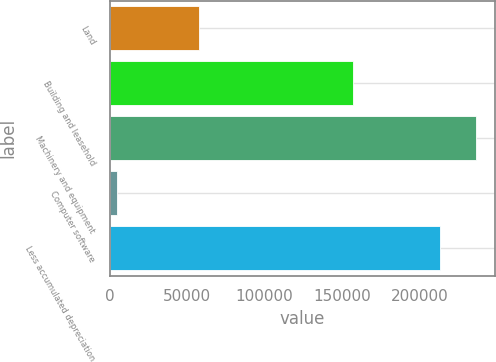Convert chart to OTSL. <chart><loc_0><loc_0><loc_500><loc_500><bar_chart><fcel>Land<fcel>Building and leasehold<fcel>Machinery and equipment<fcel>Computer software<fcel>Less accumulated depreciation<nl><fcel>57478<fcel>156918<fcel>236874<fcel>5016<fcel>213577<nl></chart> 